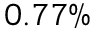Convert formula to latex. <formula><loc_0><loc_0><loc_500><loc_500>0 . 7 7 \%</formula> 